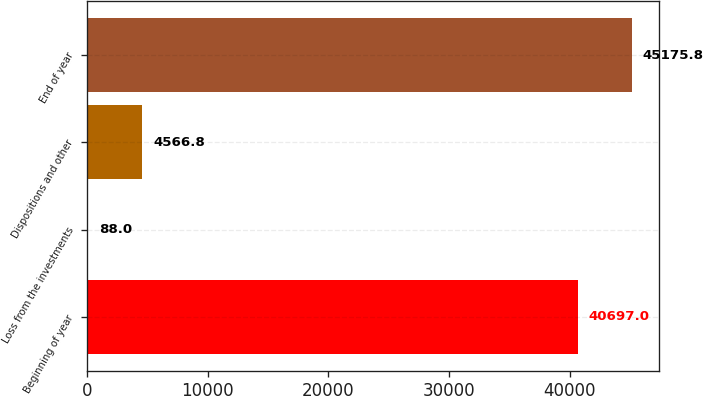<chart> <loc_0><loc_0><loc_500><loc_500><bar_chart><fcel>Beginning of year<fcel>Loss from the investments<fcel>Dispositions and other<fcel>End of year<nl><fcel>40697<fcel>88<fcel>4566.8<fcel>45175.8<nl></chart> 